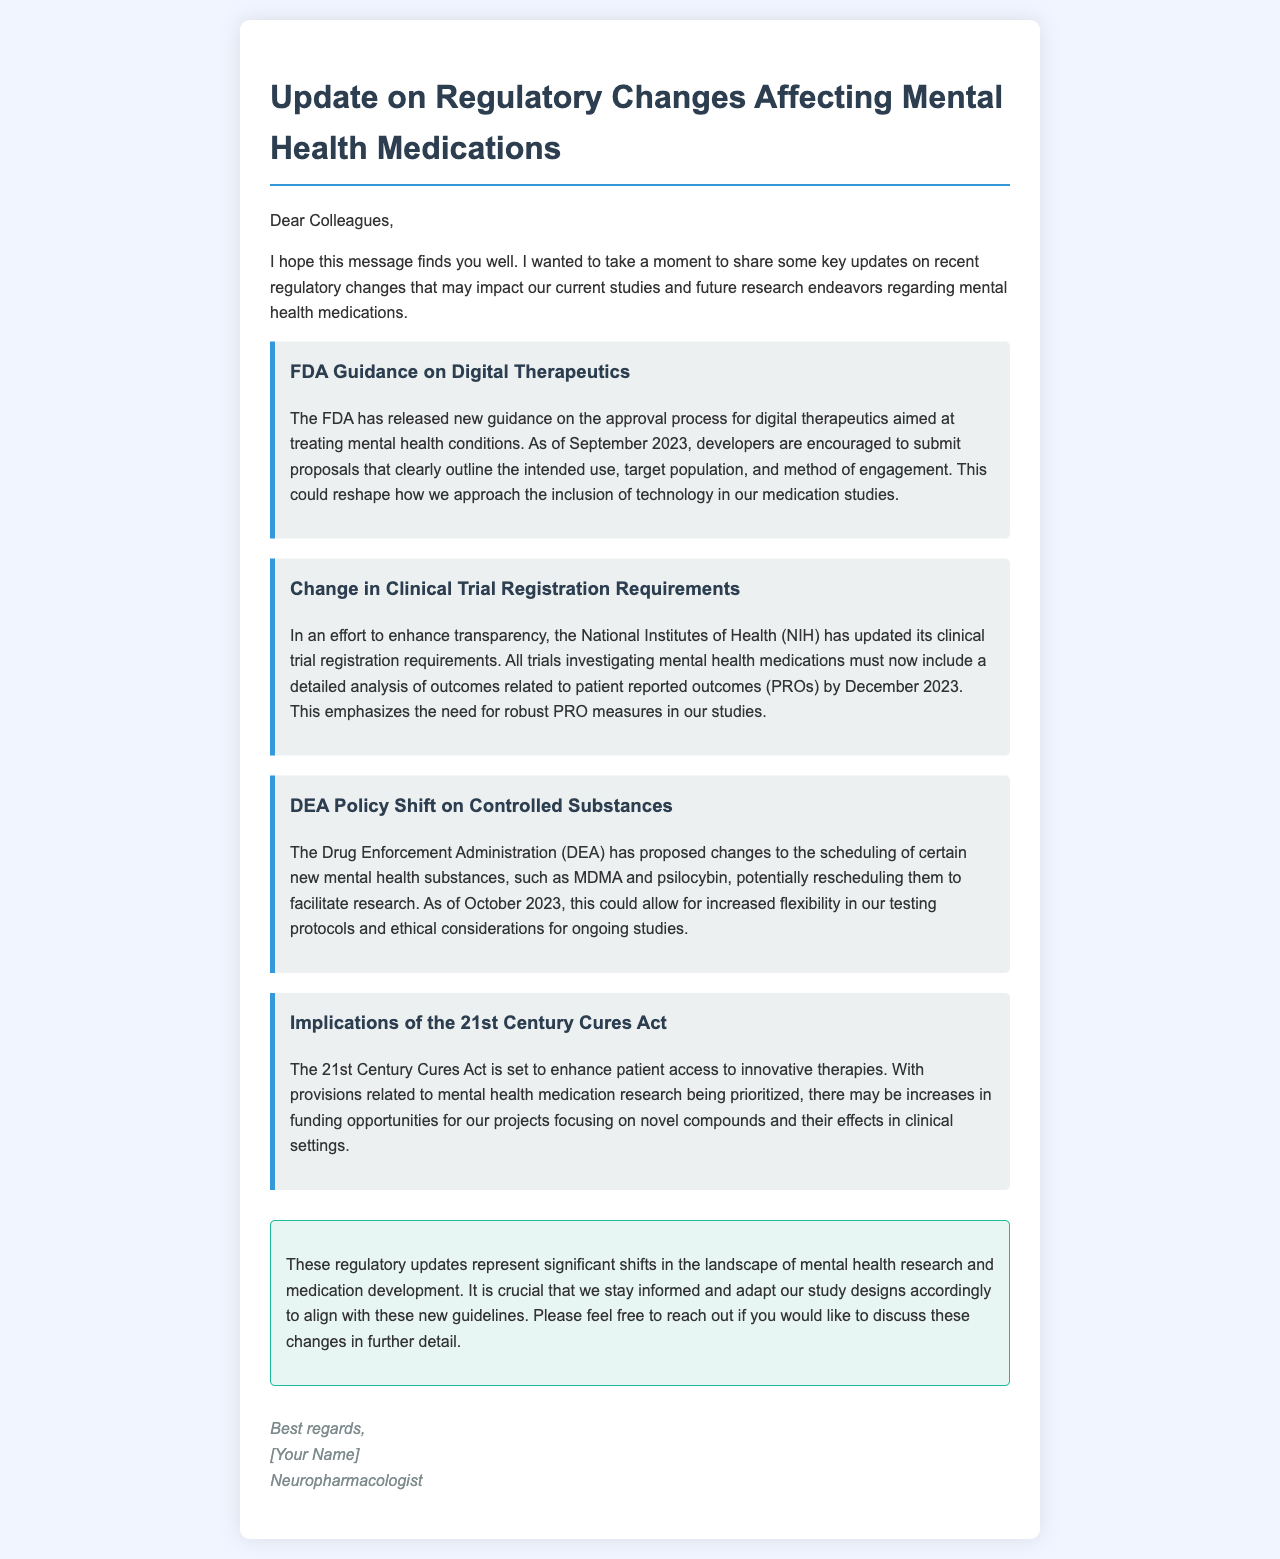What regulatory body released new guidance on digital therapeutics? The regulatory body that released the guidance is the FDA.
Answer: FDA What is required by the NIH for clinical trials investigating mental health medications? The NIH requires trials to include a detailed analysis of outcomes related to patient reported outcomes (PROs).
Answer: PROs When must detailed PRO analysis be included in trials? The deadline for including detailed PRO analysis is December 2023.
Answer: December 2023 What substances are being considered for rescheduling by the DEA? The substances being considered for rescheduling include MDMA and psilocybin.
Answer: MDMA and psilocybin What act is enhancing patient access to innovative therapies? The act that is enhancing patient access is the 21st Century Cures Act.
Answer: 21st Century Cures Act Which regulatory change emphasizes the need for robust patient reported outcomes measures? The change in clinical trial registration requirements by the NIH emphasizes this need.
Answer: NIH clinical trial registration What is a potential outcome of the regulatory changes discussed in the document? A potential outcome is increased funding opportunities for projects focusing on novel compounds.
Answer: Increased funding opportunities What month and year was the FDA guidance on digital therapeutics released? The FDA guidance was released in September 2023.
Answer: September 2023 Which agency proposed changes to the scheduling of new mental health substances? The agency that proposed changes is the DEA.
Answer: DEA 